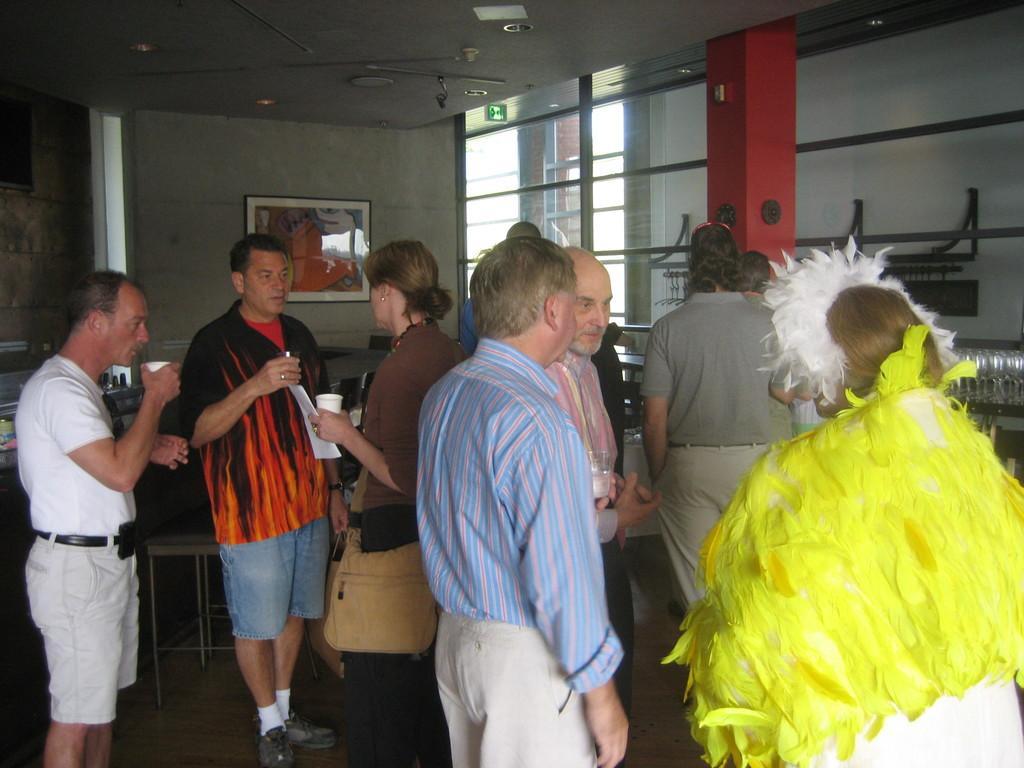Can you describe this image briefly? In this image, we can see there are persons in different color dresses, standing. Some of them are holding glasses. In the background, there is a photo frame attached to the wall, there is a glass window, a red color pillar and other objects. 